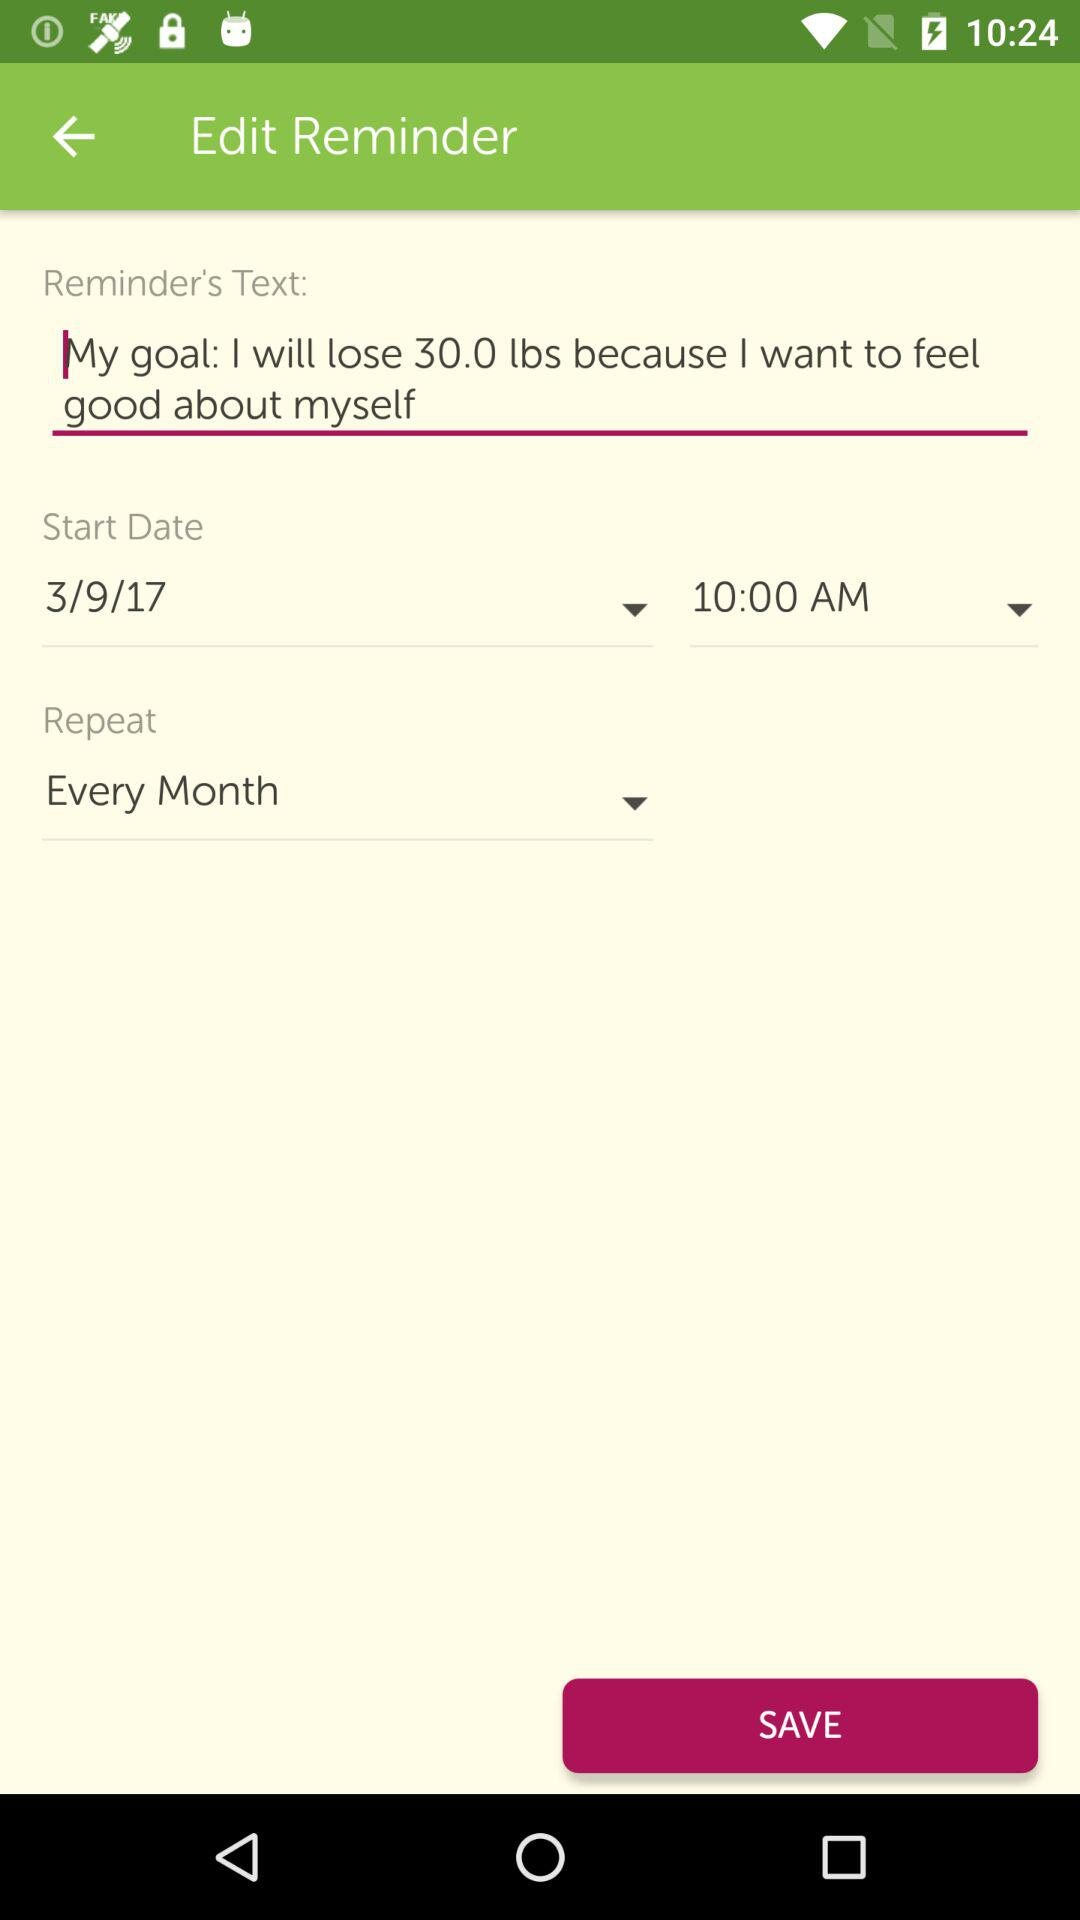What is the time of the reminder?
Answer the question using a single word or phrase. 10:00 AM 